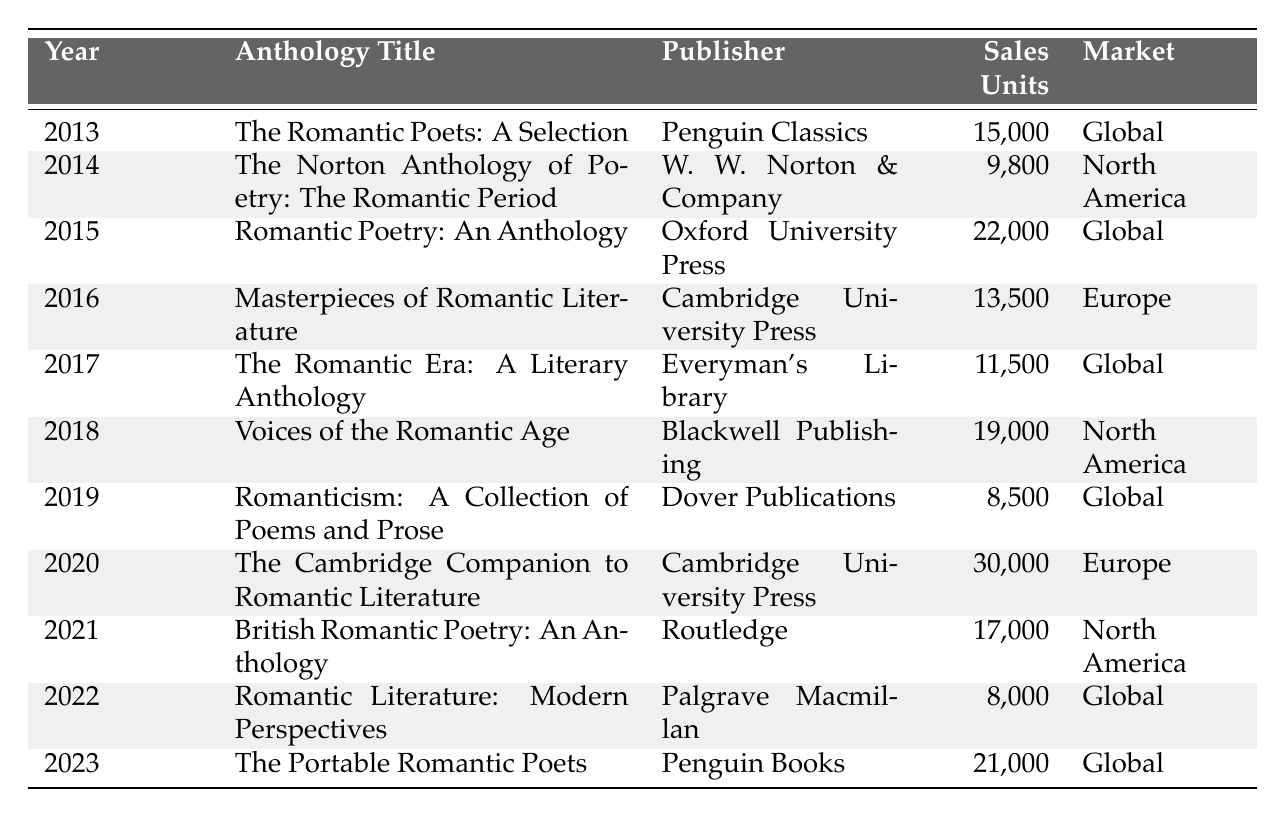What was the sales figure for "The Cambridge Companion to Romantic Literature" in 2020? The table shows that "The Cambridge Companion to Romantic Literature" had sales of 30,000 units in 2020.
Answer: 30,000 Which anthology had the highest sales units in the year 2015? According to the table, "Romantic Poetry: An Anthology" had the highest sales units in 2015 with 22,000 units.
Answer: 22,000 How many units were sold for all anthologies in 2016? The sales units for anthologies in 2016 include Masterpieces of Romantic Literature (13,500) and The Romantic Era: A Literary Anthology (11,500). Adding these gives 13,500 + 11,500 = 25,000.
Answer: 25,000 What was the total sales across all years for anthologies published by Cambridge University Press? The relevant sales figures from the table for Cambridge University Press are 13,500 (2016) and 30,000 (2020). Summing these gives 13,500 + 30,000 = 43,500.
Answer: 43,500 Which anthology had the lowest sales units in 2022, and how many units were sold? "Romantic Literature: Modern Perspectives" had the lowest sales in 2022 with 8,000 units as shown in the table.
Answer: 8,000 Was the anthology "Voices of the Romantic Age" published by a publisher based in Europe? The table indicates that "Voices of the Romantic Age" was published by Blackwell Publishing, which is not based in Europe, but in North America.
Answer: No What is the market reach of the anthology with the highest sales in 2020? The anthology with the highest sales in 2020 was "The Cambridge Companion to Romantic Literature" with sales of 30,000 units, and its market reach is Europe as indicated in the table.
Answer: Europe Over the period of 2013 to 2023, how many years saw sales units exceeding 20,000? Reviewing the table, the years with sales exceeding 20,000 units are 2015 (22,000), 2020 (30,000), and 2023 (21,000). This accounts for 3 years in total.
Answer: 3 years What is the difference in sales units between the highest and lowest selling anthologies in 2019? The anthology with the highest sales in 2019 was "Romanticism: A Collection of Poems and Prose" with 8,500 units, and for the year 2019, it had the only listing with 8,500 units; so the difference is 8,500 - 8,500 = 0.
Answer: 0 Which anthology showed an increase in sales units compared to the previous year, specifically in 2021 compared to 2020? In 2020, "The Cambridge Companion to Romantic Literature" had 30,000 units, and in 2021, "British Romantic Poetry: An Anthology" had 17,000 units, indicating a decrease from 30,000 to 17,000.
Answer: No 